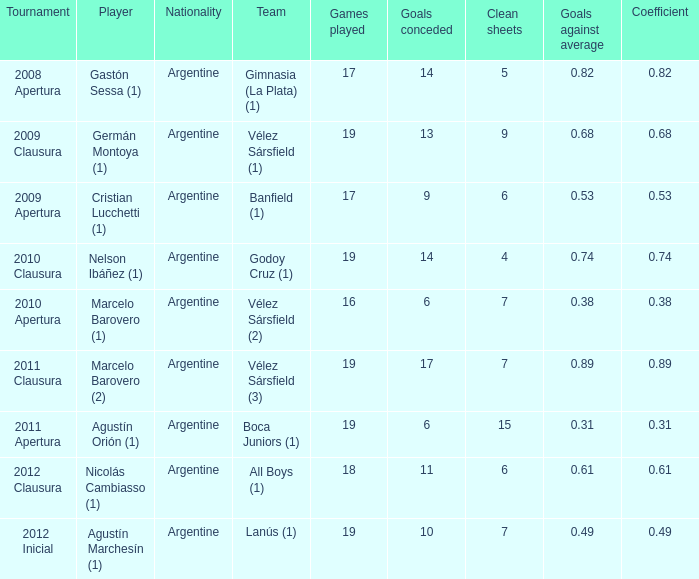How many nationalities are there for the 2011 apertura? 1.0. 